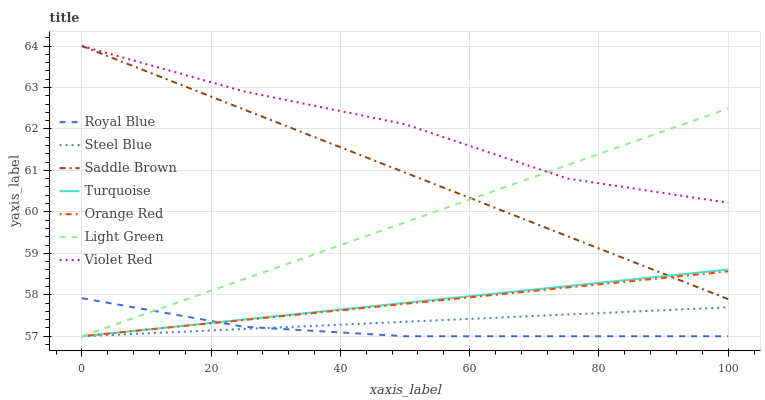Does Steel Blue have the minimum area under the curve?
Answer yes or no. No. Does Steel Blue have the maximum area under the curve?
Answer yes or no. No. Is Steel Blue the smoothest?
Answer yes or no. No. Is Steel Blue the roughest?
Answer yes or no. No. Does Violet Red have the lowest value?
Answer yes or no. No. Does Steel Blue have the highest value?
Answer yes or no. No. Is Orange Red less than Violet Red?
Answer yes or no. Yes. Is Violet Red greater than Orange Red?
Answer yes or no. Yes. Does Orange Red intersect Violet Red?
Answer yes or no. No. 